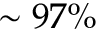Convert formula to latex. <formula><loc_0><loc_0><loc_500><loc_500>\sim 9 7 \%</formula> 